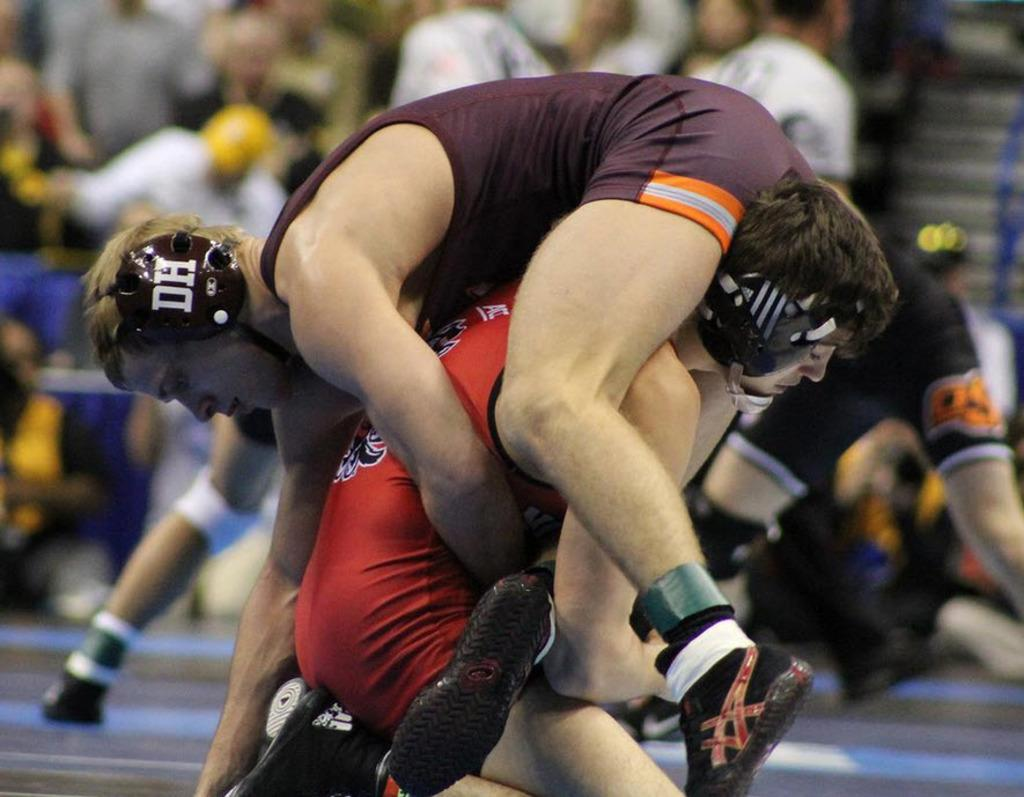<image>
Relay a brief, clear account of the picture shown. A wrestler wearing a DH headpiece is being lifted off the ground. 